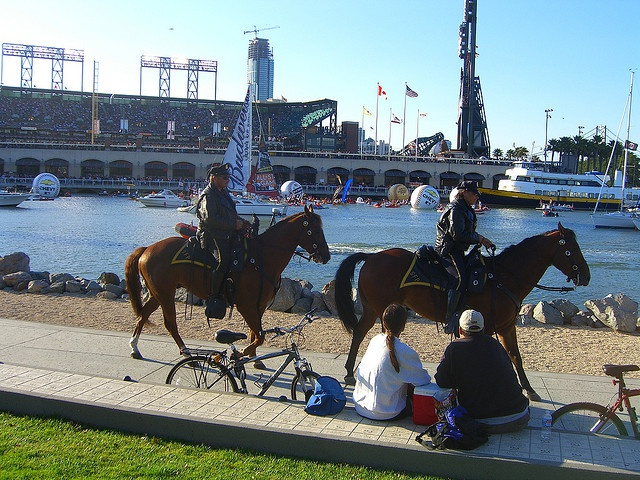Describe the objects in this image and their specific colors. I can see horse in white, black, gray, olive, and maroon tones, horse in white, black, maroon, and gray tones, boat in white, black, darkgray, navy, and gray tones, people in white, black, gray, navy, and darkblue tones, and bicycle in white, black, darkgray, and gray tones in this image. 